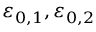<formula> <loc_0><loc_0><loc_500><loc_500>\varepsilon _ { 0 , 1 } , \varepsilon _ { 0 , 2 }</formula> 